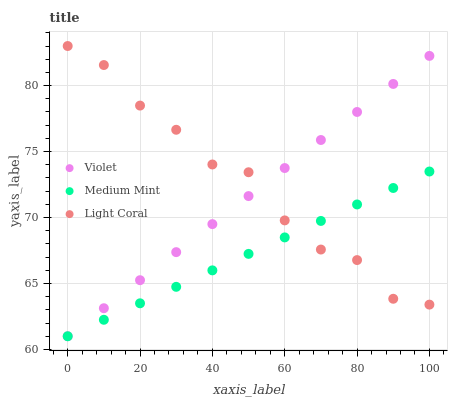Does Medium Mint have the minimum area under the curve?
Answer yes or no. Yes. Does Light Coral have the maximum area under the curve?
Answer yes or no. Yes. Does Violet have the minimum area under the curve?
Answer yes or no. No. Does Violet have the maximum area under the curve?
Answer yes or no. No. Is Medium Mint the smoothest?
Answer yes or no. Yes. Is Light Coral the roughest?
Answer yes or no. Yes. Is Violet the smoothest?
Answer yes or no. No. Is Violet the roughest?
Answer yes or no. No. Does Medium Mint have the lowest value?
Answer yes or no. Yes. Does Light Coral have the lowest value?
Answer yes or no. No. Does Light Coral have the highest value?
Answer yes or no. Yes. Does Violet have the highest value?
Answer yes or no. No. Does Violet intersect Light Coral?
Answer yes or no. Yes. Is Violet less than Light Coral?
Answer yes or no. No. Is Violet greater than Light Coral?
Answer yes or no. No. 